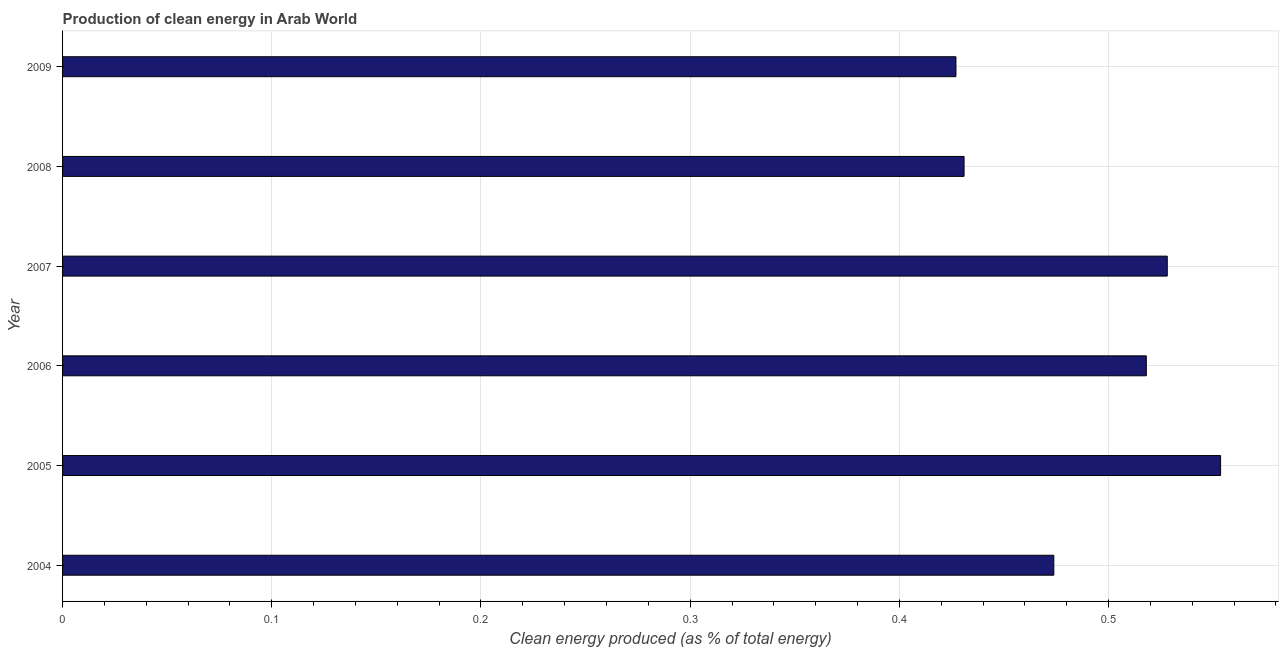Does the graph contain any zero values?
Make the answer very short. No. What is the title of the graph?
Offer a terse response. Production of clean energy in Arab World. What is the label or title of the X-axis?
Your answer should be very brief. Clean energy produced (as % of total energy). What is the production of clean energy in 2006?
Give a very brief answer. 0.52. Across all years, what is the maximum production of clean energy?
Offer a terse response. 0.55. Across all years, what is the minimum production of clean energy?
Provide a short and direct response. 0.43. In which year was the production of clean energy maximum?
Ensure brevity in your answer.  2005. What is the sum of the production of clean energy?
Offer a terse response. 2.93. What is the difference between the production of clean energy in 2006 and 2007?
Keep it short and to the point. -0.01. What is the average production of clean energy per year?
Provide a short and direct response. 0.49. What is the median production of clean energy?
Ensure brevity in your answer.  0.5. In how many years, is the production of clean energy greater than 0.04 %?
Ensure brevity in your answer.  6. Do a majority of the years between 2004 and 2005 (inclusive) have production of clean energy greater than 0.2 %?
Give a very brief answer. Yes. What is the ratio of the production of clean energy in 2004 to that in 2008?
Give a very brief answer. 1.1. What is the difference between the highest and the second highest production of clean energy?
Keep it short and to the point. 0.03. What is the difference between the highest and the lowest production of clean energy?
Ensure brevity in your answer.  0.13. In how many years, is the production of clean energy greater than the average production of clean energy taken over all years?
Offer a terse response. 3. Are all the bars in the graph horizontal?
Keep it short and to the point. Yes. How many years are there in the graph?
Offer a terse response. 6. What is the difference between two consecutive major ticks on the X-axis?
Your response must be concise. 0.1. What is the Clean energy produced (as % of total energy) of 2004?
Offer a terse response. 0.47. What is the Clean energy produced (as % of total energy) in 2005?
Your answer should be compact. 0.55. What is the Clean energy produced (as % of total energy) of 2006?
Keep it short and to the point. 0.52. What is the Clean energy produced (as % of total energy) in 2007?
Give a very brief answer. 0.53. What is the Clean energy produced (as % of total energy) of 2008?
Your answer should be compact. 0.43. What is the Clean energy produced (as % of total energy) in 2009?
Offer a very short reply. 0.43. What is the difference between the Clean energy produced (as % of total energy) in 2004 and 2005?
Offer a terse response. -0.08. What is the difference between the Clean energy produced (as % of total energy) in 2004 and 2006?
Offer a very short reply. -0.04. What is the difference between the Clean energy produced (as % of total energy) in 2004 and 2007?
Offer a terse response. -0.05. What is the difference between the Clean energy produced (as % of total energy) in 2004 and 2008?
Your answer should be very brief. 0.04. What is the difference between the Clean energy produced (as % of total energy) in 2004 and 2009?
Offer a very short reply. 0.05. What is the difference between the Clean energy produced (as % of total energy) in 2005 and 2006?
Ensure brevity in your answer.  0.04. What is the difference between the Clean energy produced (as % of total energy) in 2005 and 2007?
Keep it short and to the point. 0.03. What is the difference between the Clean energy produced (as % of total energy) in 2005 and 2008?
Provide a succinct answer. 0.12. What is the difference between the Clean energy produced (as % of total energy) in 2005 and 2009?
Provide a succinct answer. 0.13. What is the difference between the Clean energy produced (as % of total energy) in 2006 and 2007?
Keep it short and to the point. -0.01. What is the difference between the Clean energy produced (as % of total energy) in 2006 and 2008?
Offer a terse response. 0.09. What is the difference between the Clean energy produced (as % of total energy) in 2006 and 2009?
Provide a short and direct response. 0.09. What is the difference between the Clean energy produced (as % of total energy) in 2007 and 2008?
Your answer should be compact. 0.1. What is the difference between the Clean energy produced (as % of total energy) in 2007 and 2009?
Provide a short and direct response. 0.1. What is the difference between the Clean energy produced (as % of total energy) in 2008 and 2009?
Provide a short and direct response. 0. What is the ratio of the Clean energy produced (as % of total energy) in 2004 to that in 2005?
Provide a succinct answer. 0.86. What is the ratio of the Clean energy produced (as % of total energy) in 2004 to that in 2006?
Provide a succinct answer. 0.92. What is the ratio of the Clean energy produced (as % of total energy) in 2004 to that in 2007?
Offer a terse response. 0.9. What is the ratio of the Clean energy produced (as % of total energy) in 2004 to that in 2009?
Your response must be concise. 1.11. What is the ratio of the Clean energy produced (as % of total energy) in 2005 to that in 2006?
Ensure brevity in your answer.  1.07. What is the ratio of the Clean energy produced (as % of total energy) in 2005 to that in 2007?
Keep it short and to the point. 1.05. What is the ratio of the Clean energy produced (as % of total energy) in 2005 to that in 2008?
Ensure brevity in your answer.  1.28. What is the ratio of the Clean energy produced (as % of total energy) in 2005 to that in 2009?
Keep it short and to the point. 1.3. What is the ratio of the Clean energy produced (as % of total energy) in 2006 to that in 2007?
Provide a short and direct response. 0.98. What is the ratio of the Clean energy produced (as % of total energy) in 2006 to that in 2008?
Your answer should be compact. 1.2. What is the ratio of the Clean energy produced (as % of total energy) in 2006 to that in 2009?
Give a very brief answer. 1.21. What is the ratio of the Clean energy produced (as % of total energy) in 2007 to that in 2008?
Your answer should be very brief. 1.23. What is the ratio of the Clean energy produced (as % of total energy) in 2007 to that in 2009?
Provide a short and direct response. 1.24. What is the ratio of the Clean energy produced (as % of total energy) in 2008 to that in 2009?
Offer a terse response. 1.01. 